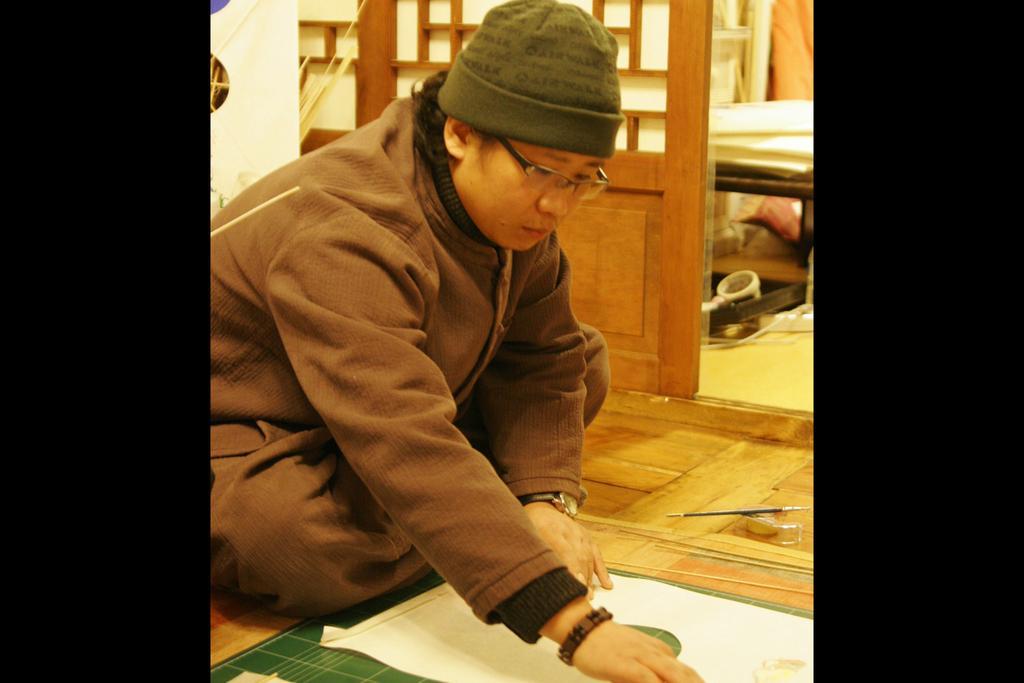Can you describe this image briefly? In this image in the center there is one man who sitting and he is drawing something, in front of him there is one paper and a painting brush. In the background there is a wooden door, bed and some other objects. 